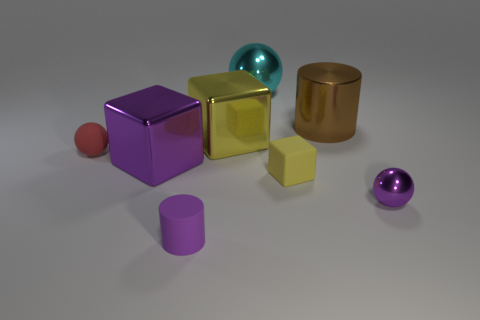Add 2 gray things. How many objects exist? 10 Subtract all balls. How many objects are left? 5 Add 8 yellow shiny blocks. How many yellow shiny blocks exist? 9 Subtract 0 brown spheres. How many objects are left? 8 Subtract all large metal blocks. Subtract all big yellow metallic things. How many objects are left? 5 Add 3 cubes. How many cubes are left? 6 